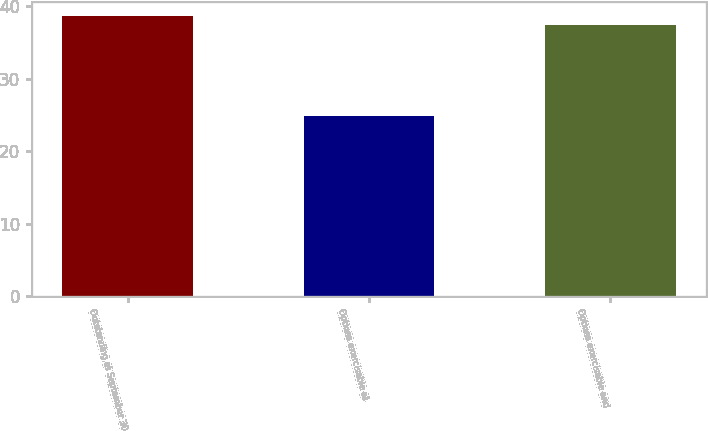Convert chart. <chart><loc_0><loc_0><loc_500><loc_500><bar_chart><fcel>Outstanding at September 30<fcel>Options exercisable at<fcel>Options exercisable and<nl><fcel>38.7<fcel>24.87<fcel>37.35<nl></chart> 